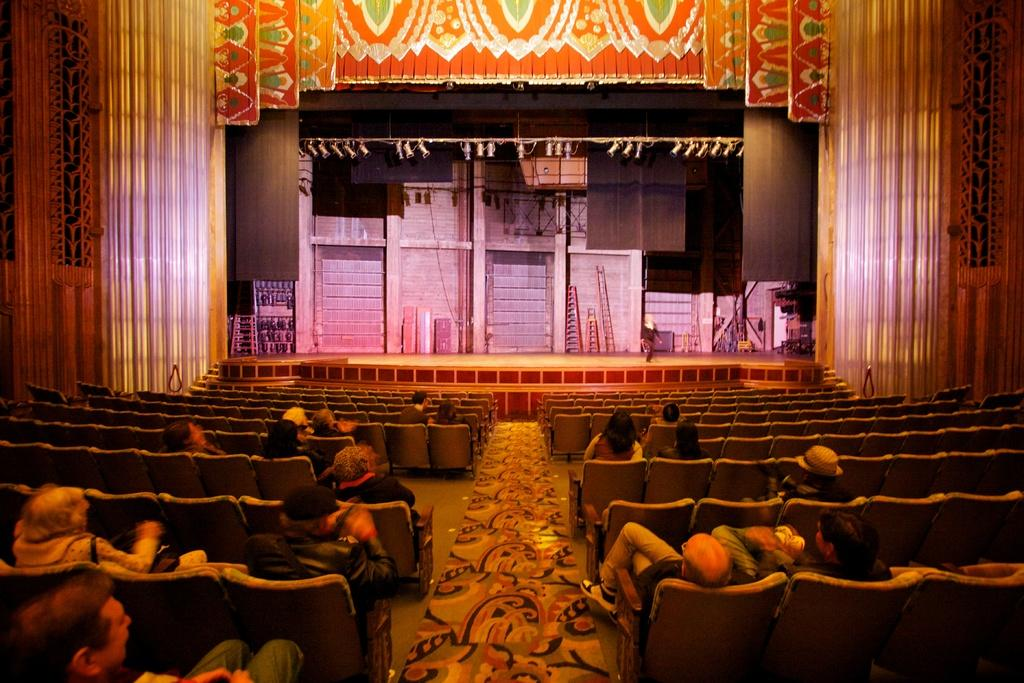What are the people in the image doing? The people in the image are sitting on chairs. What is happening in the background of the image? There is a person on a stage performing in the background. What else can be seen in the background of the image? There are objects and lights visible in the background. What type of architectural feature is present in the background? There is a wall in the background. What type of decorative element is present in the background? There is a curtain in the background. What type of pail is being used by the person on stage in the image? There is no pail visible in the image, and the person on stage is not using any pail. Can you hear the kitten's voice in the image? There is no kitten present in the image, so it is not possible to hear its voice. 